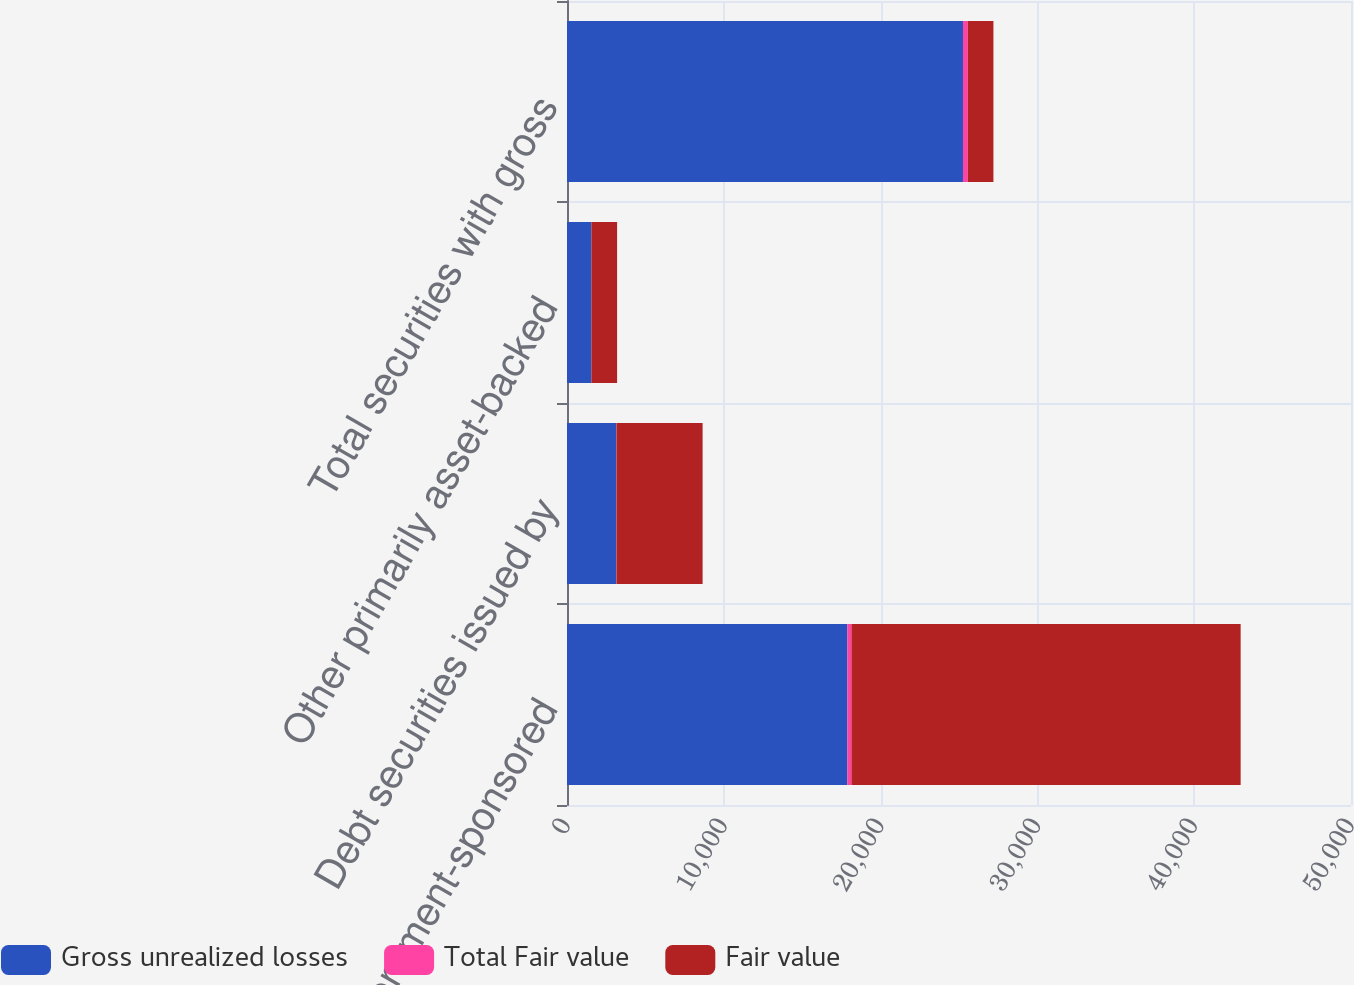Convert chart. <chart><loc_0><loc_0><loc_500><loc_500><stacked_bar_chart><ecel><fcel>US government-sponsored<fcel>Debt securities issued by<fcel>Other primarily asset-backed<fcel>Total securities with gross<nl><fcel>Gross unrealized losses<fcel>17877<fcel>3141<fcel>1556<fcel>25254<nl><fcel>Total Fair value<fcel>262<fcel>13<fcel>1<fcel>304<nl><fcel>Fair value<fcel>24823<fcel>5495<fcel>1638<fcel>1638<nl></chart> 